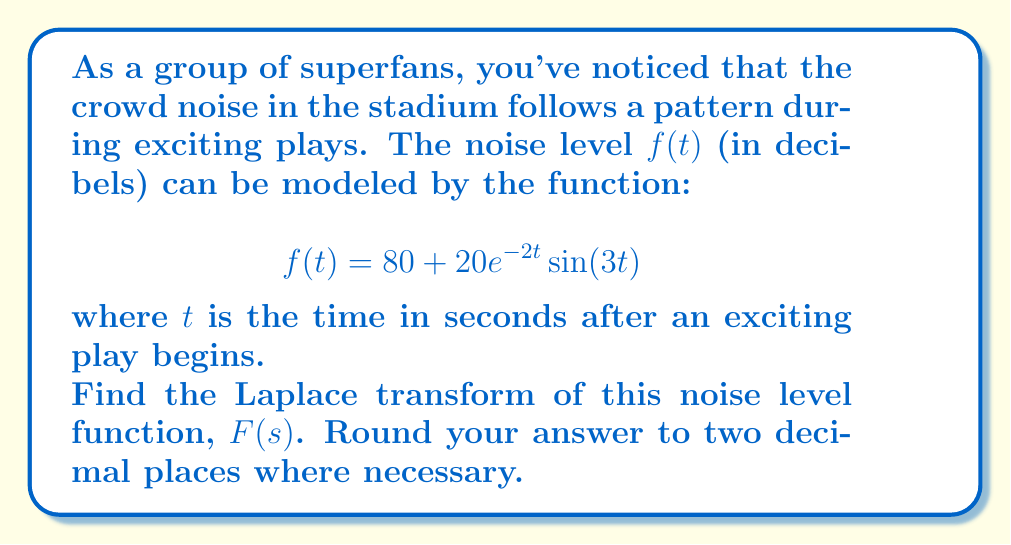Show me your answer to this math problem. Let's approach this step-by-step:

1) The Laplace transform of $f(t)$ is given by:
   $$F(s) = \mathcal{L}\{f(t)\} = \int_0^\infty f(t)e^{-st}dt$$

2) We need to transform $f(t) = 80 + 20e^{-2t}\sin(3t)$. Let's break it into two parts:
   
   a) $\mathcal{L}\{80\} = \frac{80}{s}$ (constant function)
   
   b) $\mathcal{L}\{20e^{-2t}\sin(3t)\}$

3) For the second part, we can use the Laplace transform of $e^{at}\sin(bt)$:
   $$\mathcal{L}\{e^{at}\sin(bt)\} = \frac{b}{(s-a)^2 + b^2}$$

4) In our case, $a = -2$ and $b = 3$. Also, we have a factor of 20. So:
   $$\mathcal{L}\{20e^{-2t}\sin(3t)\} = 20 \cdot \frac{3}{(s+2)^2 + 3^2}$$

5) Simplifying:
   $$\mathcal{L}\{20e^{-2t}\sin(3t)\} = \frac{60}{(s+2)^2 + 9}$$

6) Combining both parts:
   $$F(s) = \frac{80}{s} + \frac{60}{(s+2)^2 + 9}$$

7) This is our final answer. No further simplification is necessary.
Answer: $$F(s) = \frac{80}{s} + \frac{60}{(s+2)^2 + 9}$$ 